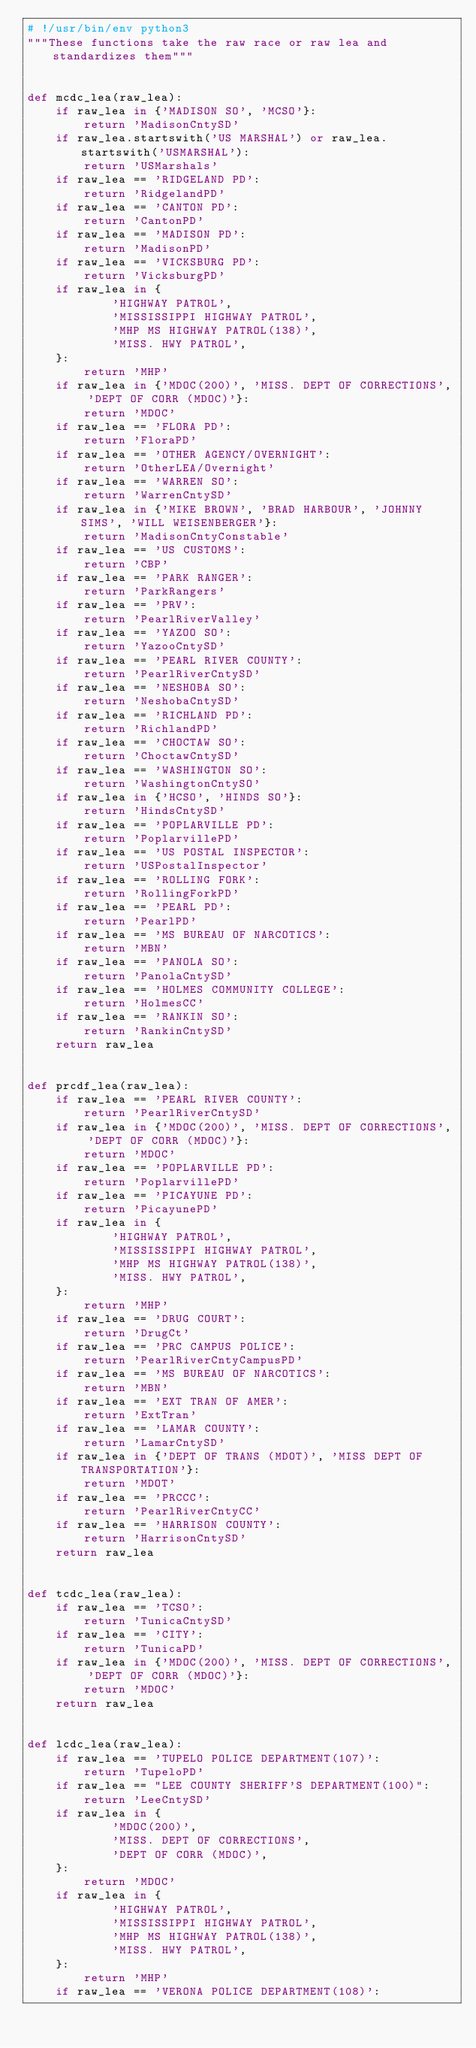Convert code to text. <code><loc_0><loc_0><loc_500><loc_500><_Python_># !/usr/bin/env python3
"""These functions take the raw race or raw lea and standardizes them"""


def mcdc_lea(raw_lea):
    if raw_lea in {'MADISON SO', 'MCSO'}:
        return 'MadisonCntySD'
    if raw_lea.startswith('US MARSHAL') or raw_lea.startswith('USMARSHAL'):
        return 'USMarshals'
    if raw_lea == 'RIDGELAND PD':
        return 'RidgelandPD'
    if raw_lea == 'CANTON PD':
        return 'CantonPD'
    if raw_lea == 'MADISON PD':
        return 'MadisonPD'
    if raw_lea == 'VICKSBURG PD':
        return 'VicksburgPD'
    if raw_lea in {
            'HIGHWAY PATROL',
            'MISSISSIPPI HIGHWAY PATROL',
            'MHP MS HIGHWAY PATROL(138)',
            'MISS. HWY PATROL',
    }:
        return 'MHP'
    if raw_lea in {'MDOC(200)', 'MISS. DEPT OF CORRECTIONS', 'DEPT OF CORR (MDOC)'}:
        return 'MDOC'
    if raw_lea == 'FLORA PD':
        return 'FloraPD'
    if raw_lea == 'OTHER AGENCY/OVERNIGHT':
        return 'OtherLEA/Overnight'
    if raw_lea == 'WARREN SO':
        return 'WarrenCntySD'
    if raw_lea in {'MIKE BROWN', 'BRAD HARBOUR', 'JOHNNY SIMS', 'WILL WEISENBERGER'}:
        return 'MadisonCntyConstable'
    if raw_lea == 'US CUSTOMS':
        return 'CBP'
    if raw_lea == 'PARK RANGER':
        return 'ParkRangers'
    if raw_lea == 'PRV':
        return 'PearlRiverValley'
    if raw_lea == 'YAZOO SO':
        return 'YazooCntySD'
    if raw_lea == 'PEARL RIVER COUNTY':
        return 'PearlRiverCntySD'
    if raw_lea == 'NESHOBA SO':
        return 'NeshobaCntySD'
    if raw_lea == 'RICHLAND PD':
        return 'RichlandPD'
    if raw_lea == 'CHOCTAW SO':
        return 'ChoctawCntySD'
    if raw_lea == 'WASHINGTON SO':
        return 'WashingtonCntySO'
    if raw_lea in {'HCSO', 'HINDS SO'}:
        return 'HindsCntySD'
    if raw_lea == 'POPLARVILLE PD':
        return 'PoplarvillePD'
    if raw_lea == 'US POSTAL INSPECTOR':
        return 'USPostalInspector'
    if raw_lea == 'ROLLING FORK':
        return 'RollingForkPD'
    if raw_lea == 'PEARL PD':
        return 'PearlPD'
    if raw_lea == 'MS BUREAU OF NARCOTICS':
        return 'MBN'
    if raw_lea == 'PANOLA SO':
        return 'PanolaCntySD'
    if raw_lea == 'HOLMES COMMUNITY COLLEGE':
        return 'HolmesCC'
    if raw_lea == 'RANKIN SO':
        return 'RankinCntySD'
    return raw_lea


def prcdf_lea(raw_lea):
    if raw_lea == 'PEARL RIVER COUNTY':
        return 'PearlRiverCntySD'
    if raw_lea in {'MDOC(200)', 'MISS. DEPT OF CORRECTIONS', 'DEPT OF CORR (MDOC)'}:
        return 'MDOC'
    if raw_lea == 'POPLARVILLE PD':
        return 'PoplarvillePD'
    if raw_lea == 'PICAYUNE PD':
        return 'PicayunePD'
    if raw_lea in {
            'HIGHWAY PATROL',
            'MISSISSIPPI HIGHWAY PATROL',
            'MHP MS HIGHWAY PATROL(138)',
            'MISS. HWY PATROL',
    }:
        return 'MHP'
    if raw_lea == 'DRUG COURT':
        return 'DrugCt'
    if raw_lea == 'PRC CAMPUS POLICE':
        return 'PearlRiverCntyCampusPD'
    if raw_lea == 'MS BUREAU OF NARCOTICS':
        return 'MBN'
    if raw_lea == 'EXT TRAN OF AMER':
        return 'ExtTran'
    if raw_lea == 'LAMAR COUNTY':
        return 'LamarCntySD'
    if raw_lea in {'DEPT OF TRANS (MDOT)', 'MISS DEPT OF TRANSPORTATION'}:
        return 'MDOT'
    if raw_lea == 'PRCCC':
        return 'PearlRiverCntyCC'
    if raw_lea == 'HARRISON COUNTY':
        return 'HarrisonCntySD'
    return raw_lea


def tcdc_lea(raw_lea):
    if raw_lea == 'TCSO':
        return 'TunicaCntySD'
    if raw_lea == 'CITY':
        return 'TunicaPD'
    if raw_lea in {'MDOC(200)', 'MISS. DEPT OF CORRECTIONS', 'DEPT OF CORR (MDOC)'}:
        return 'MDOC'
    return raw_lea


def lcdc_lea(raw_lea):
    if raw_lea == 'TUPELO POLICE DEPARTMENT(107)':
        return 'TupeloPD'
    if raw_lea == "LEE COUNTY SHERIFF'S DEPARTMENT(100)":
        return 'LeeCntySD'
    if raw_lea in {
            'MDOC(200)',
            'MISS. DEPT OF CORRECTIONS',
            'DEPT OF CORR (MDOC)',
    }:
        return 'MDOC'
    if raw_lea in {
            'HIGHWAY PATROL',
            'MISSISSIPPI HIGHWAY PATROL',
            'MHP MS HIGHWAY PATROL(138)',
            'MISS. HWY PATROL',
    }:
        return 'MHP'
    if raw_lea == 'VERONA POLICE DEPARTMENT(108)':</code> 